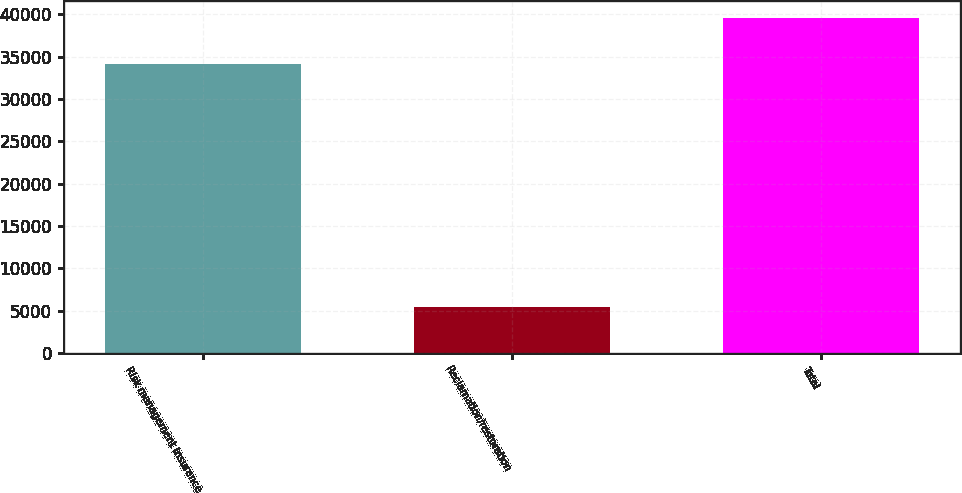<chart> <loc_0><loc_0><loc_500><loc_500><bar_chart><fcel>Risk management insurance<fcel>Reclamation/restoration<fcel>Total<nl><fcel>34111<fcel>5427<fcel>39538<nl></chart> 